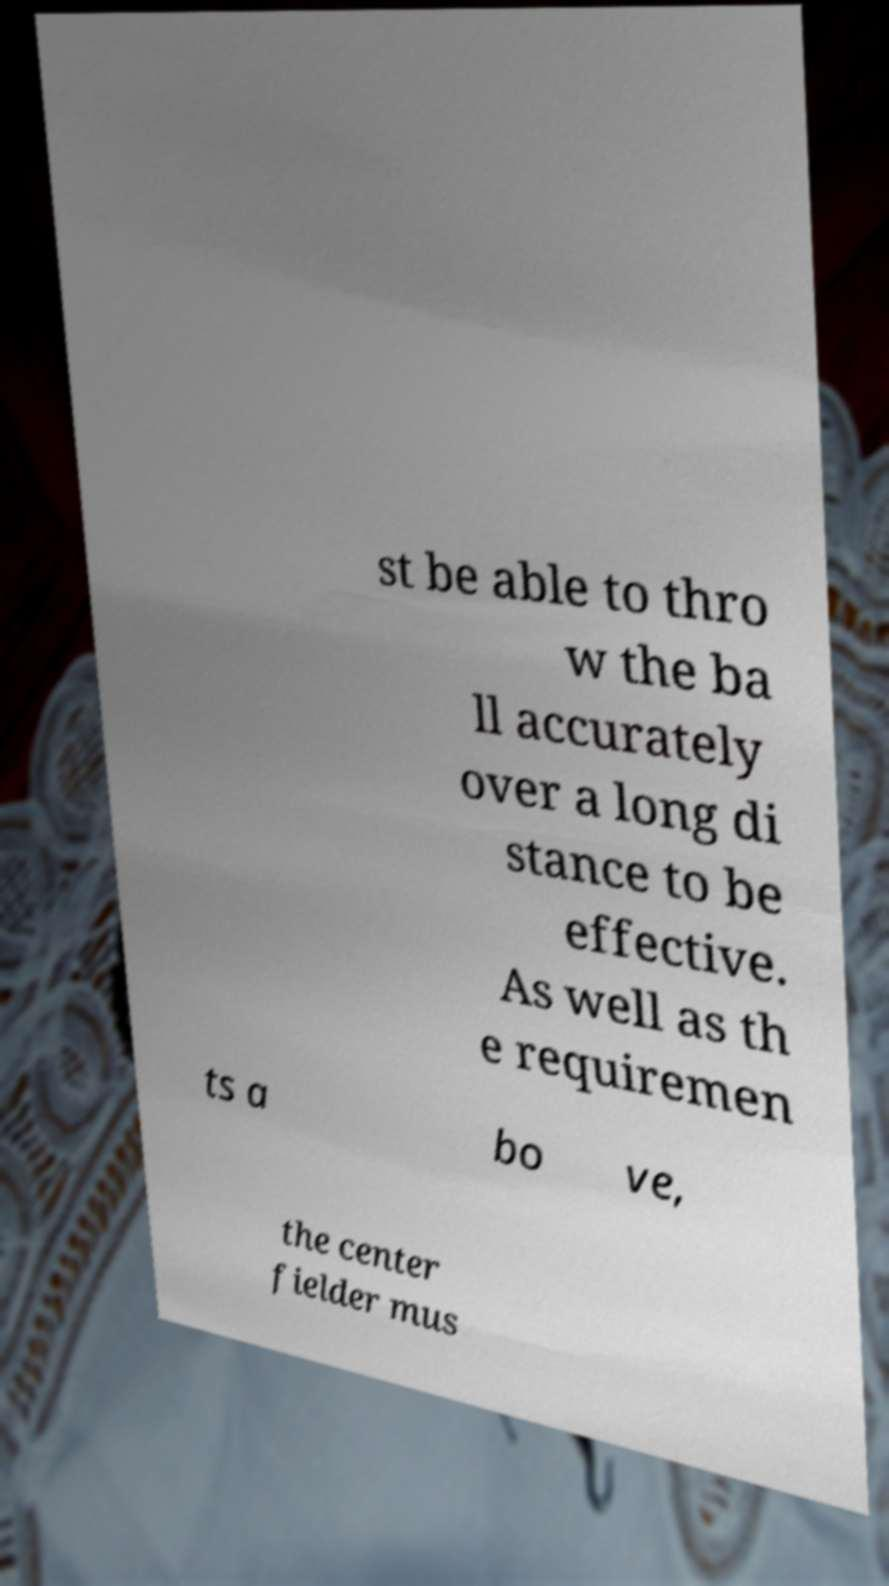Can you read and provide the text displayed in the image?This photo seems to have some interesting text. Can you extract and type it out for me? st be able to thro w the ba ll accurately over a long di stance to be effective. As well as th e requiremen ts a bo ve, the center fielder mus 